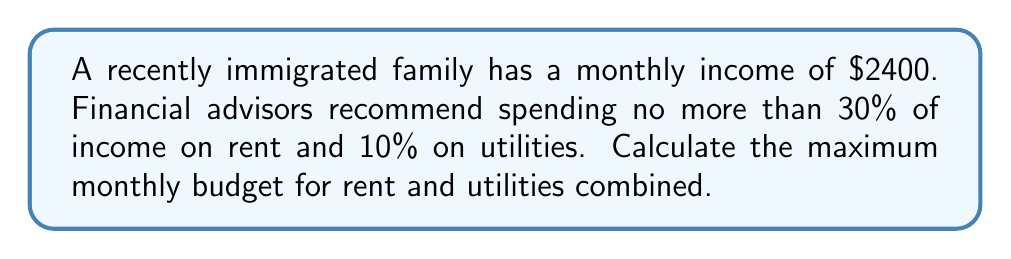Give your solution to this math problem. Let's approach this step-by-step:

1) First, we need to calculate the maximum amount for rent:
   $$ \text{Rent} = 30\% \text{ of income} = 0.30 \times \$2400 = \$720 $$

2) Next, we calculate the maximum amount for utilities:
   $$ \text{Utilities} = 10\% \text{ of income} = 0.10 \times \$2400 = \$240 $$

3) To find the total budget for rent and utilities, we add these amounts:
   $$ \text{Total Budget} = \text{Rent} + \text{Utilities} = \$720 + \$240 = \$960 $$

Therefore, the maximum monthly budget for rent and utilities combined is $960.
Answer: $960 